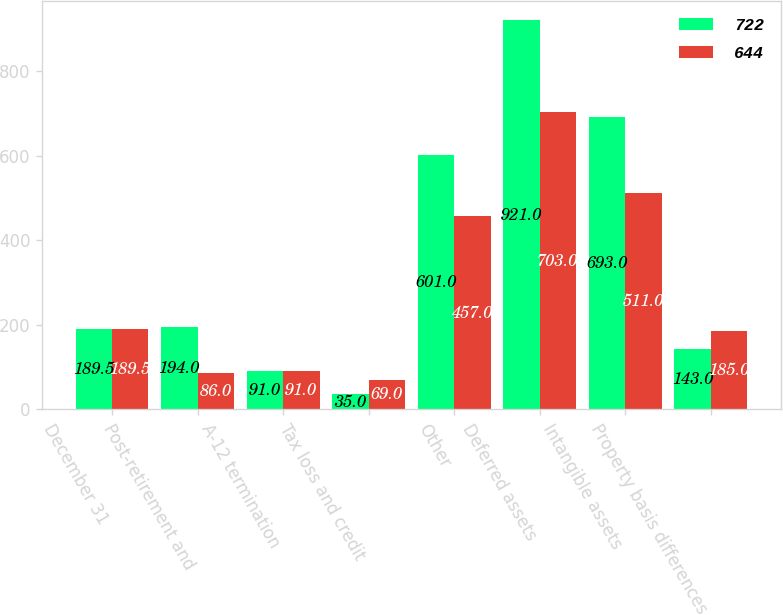Convert chart to OTSL. <chart><loc_0><loc_0><loc_500><loc_500><stacked_bar_chart><ecel><fcel>December 31<fcel>Post-retirement and<fcel>A-12 termination<fcel>Tax loss and credit<fcel>Other<fcel>Deferred assets<fcel>Intangible assets<fcel>Property basis differences<nl><fcel>722<fcel>189.5<fcel>194<fcel>91<fcel>35<fcel>601<fcel>921<fcel>693<fcel>143<nl><fcel>644<fcel>189.5<fcel>86<fcel>91<fcel>69<fcel>457<fcel>703<fcel>511<fcel>185<nl></chart> 